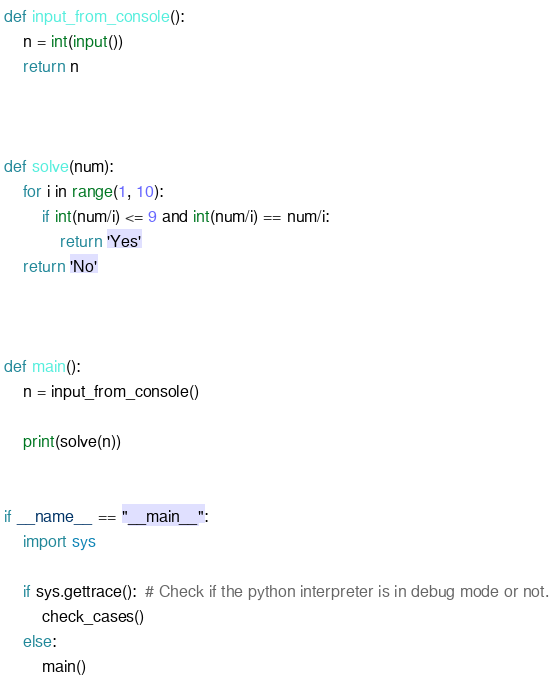Convert code to text. <code><loc_0><loc_0><loc_500><loc_500><_Python_>def input_from_console():
    n = int(input())
    return n



def solve(num):
    for i in range(1, 10):
        if int(num/i) <= 9 and int(num/i) == num/i:
            return 'Yes'
    return 'No'



def main():
    n = input_from_console()

    print(solve(n))


if __name__ == "__main__":
    import sys

    if sys.gettrace():  # Check if the python interpreter is in debug mode or not.
        check_cases()
    else:
        main()
</code> 